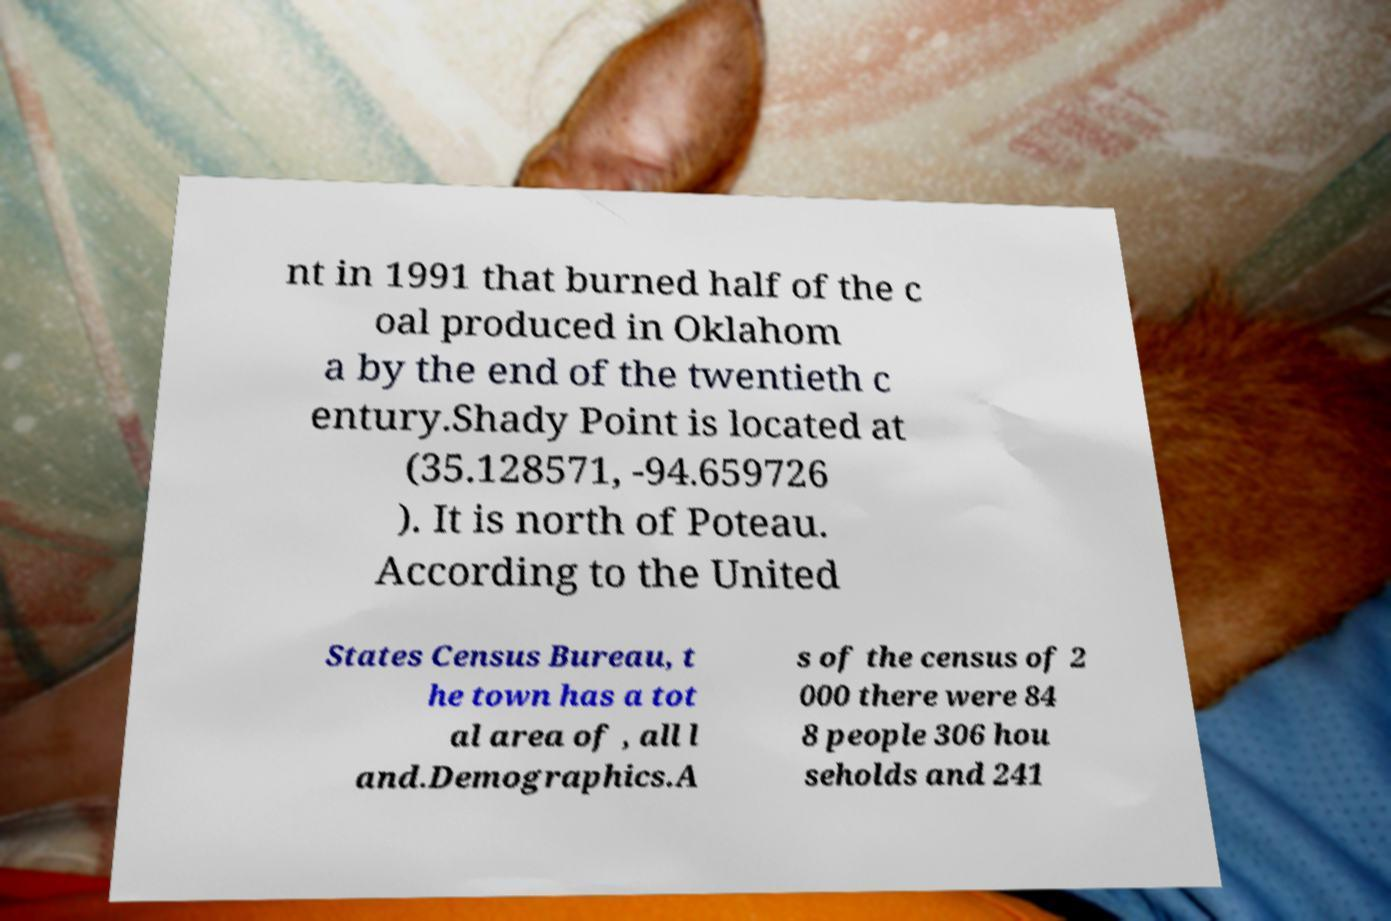Can you accurately transcribe the text from the provided image for me? nt in 1991 that burned half of the c oal produced in Oklahom a by the end of the twentieth c entury.Shady Point is located at (35.128571, -94.659726 ). It is north of Poteau. According to the United States Census Bureau, t he town has a tot al area of , all l and.Demographics.A s of the census of 2 000 there were 84 8 people 306 hou seholds and 241 